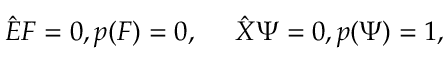<formula> <loc_0><loc_0><loc_500><loc_500>{ \hat { E } } F = 0 , p ( F ) = 0 , \quad \ { \hat { X } } \Psi = 0 , p ( \Psi ) = 1 ,</formula> 